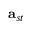Convert formula to latex. <formula><loc_0><loc_0><loc_500><loc_500>a _ { s t }</formula> 